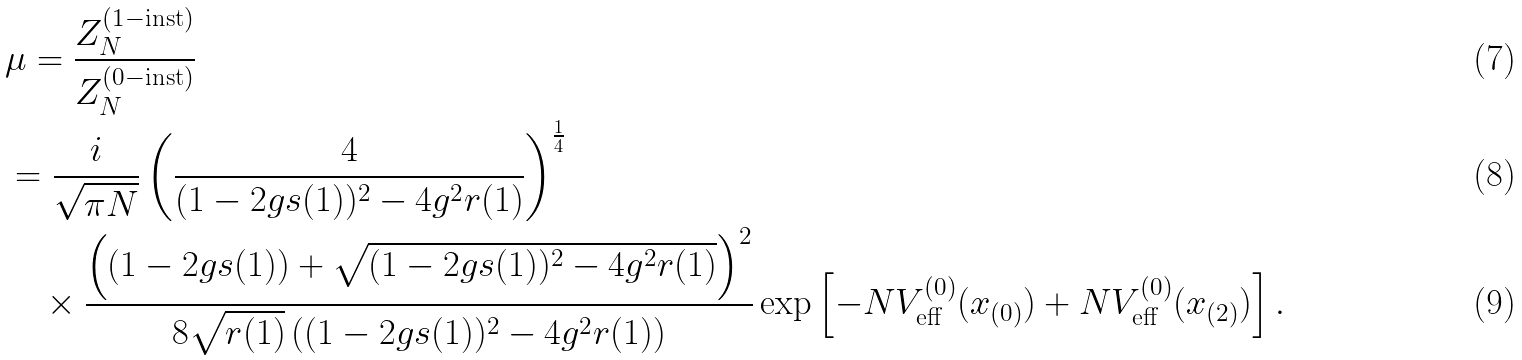Convert formula to latex. <formula><loc_0><loc_0><loc_500><loc_500>& \mu = \frac { Z _ { N } ^ { ( 1 - \text {inst} ) } } { Z _ { N } ^ { ( 0 - \text {inst} ) } } \\ & = \frac { i } { \sqrt { \pi N } } \left ( \frac { 4 } { ( 1 - 2 g s ( 1 ) ) ^ { 2 } - 4 g ^ { 2 } r ( 1 ) } \right ) ^ { \frac { 1 } { 4 } } \\ & \quad \times \frac { \left ( ( 1 - 2 g s ( 1 ) ) + \sqrt { ( 1 - 2 g s ( 1 ) ) ^ { 2 } - 4 g ^ { 2 } r ( 1 ) } \right ) ^ { 2 } } { 8 \sqrt { r ( 1 ) } \left ( ( 1 - 2 g s ( 1 ) ) ^ { 2 } - 4 g ^ { 2 } r ( 1 ) \right ) } \exp \left [ - N V _ { \text {eff} } ^ { ( 0 ) } ( x _ { ( 0 ) } ) + N V _ { \text {eff} } ^ { ( 0 ) } ( x _ { ( 2 ) } ) \right ] .</formula> 